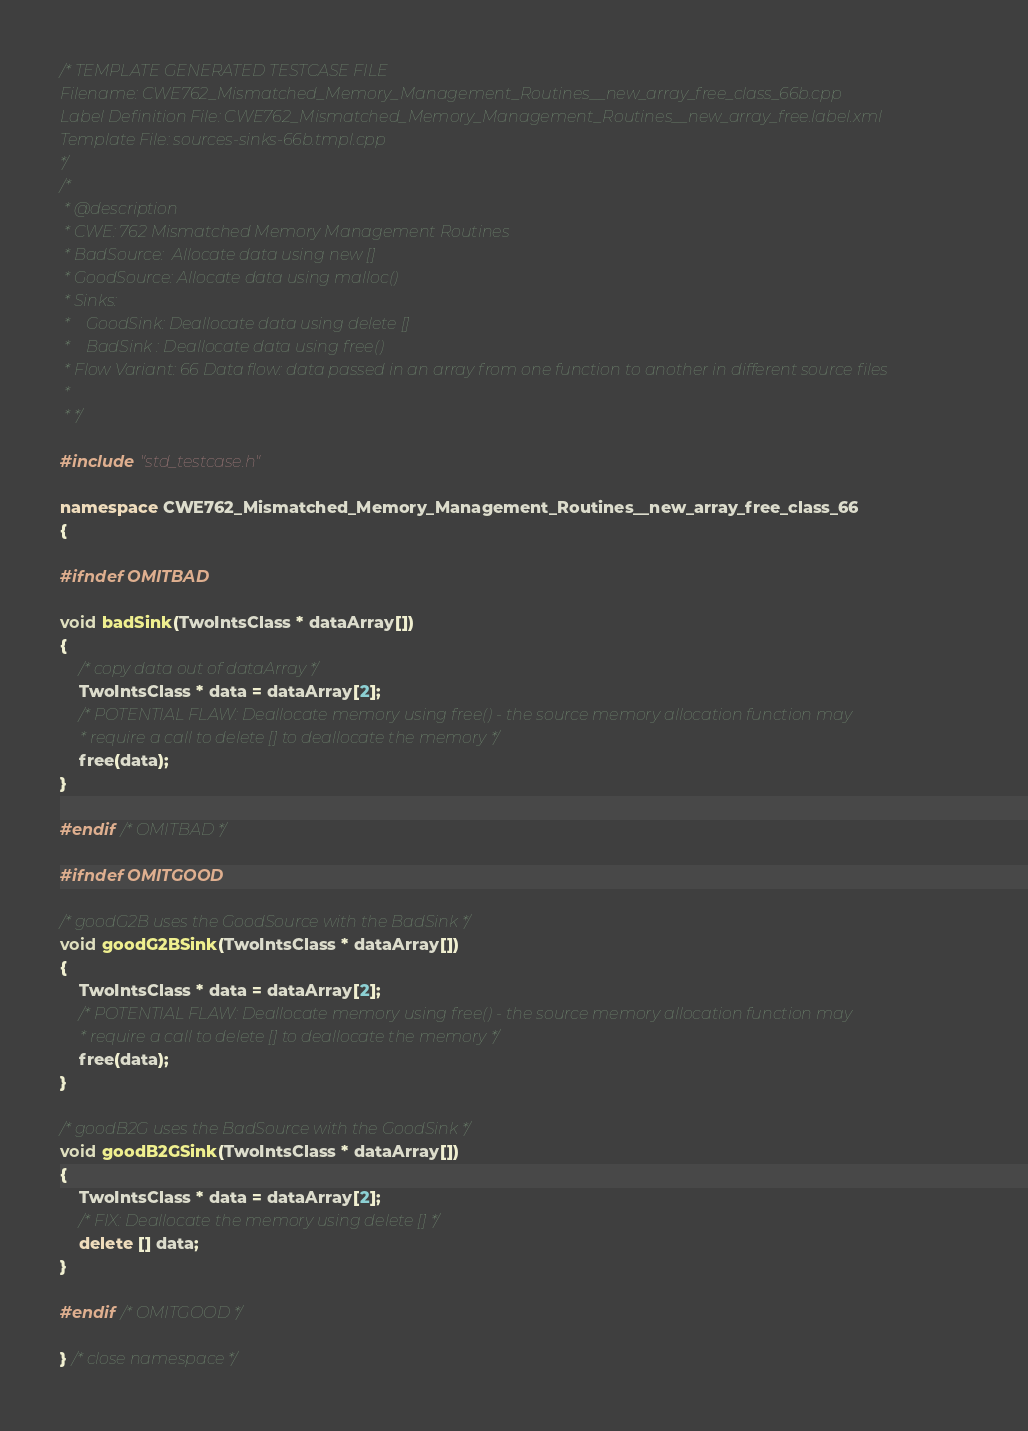<code> <loc_0><loc_0><loc_500><loc_500><_C++_>/* TEMPLATE GENERATED TESTCASE FILE
Filename: CWE762_Mismatched_Memory_Management_Routines__new_array_free_class_66b.cpp
Label Definition File: CWE762_Mismatched_Memory_Management_Routines__new_array_free.label.xml
Template File: sources-sinks-66b.tmpl.cpp
*/
/*
 * @description
 * CWE: 762 Mismatched Memory Management Routines
 * BadSource:  Allocate data using new []
 * GoodSource: Allocate data using malloc()
 * Sinks:
 *    GoodSink: Deallocate data using delete []
 *    BadSink : Deallocate data using free()
 * Flow Variant: 66 Data flow: data passed in an array from one function to another in different source files
 *
 * */

#include "std_testcase.h"

namespace CWE762_Mismatched_Memory_Management_Routines__new_array_free_class_66
{

#ifndef OMITBAD

void badSink(TwoIntsClass * dataArray[])
{
    /* copy data out of dataArray */
    TwoIntsClass * data = dataArray[2];
    /* POTENTIAL FLAW: Deallocate memory using free() - the source memory allocation function may
     * require a call to delete [] to deallocate the memory */
    free(data);
}

#endif /* OMITBAD */

#ifndef OMITGOOD

/* goodG2B uses the GoodSource with the BadSink */
void goodG2BSink(TwoIntsClass * dataArray[])
{
    TwoIntsClass * data = dataArray[2];
    /* POTENTIAL FLAW: Deallocate memory using free() - the source memory allocation function may
     * require a call to delete [] to deallocate the memory */
    free(data);
}

/* goodB2G uses the BadSource with the GoodSink */
void goodB2GSink(TwoIntsClass * dataArray[])
{
    TwoIntsClass * data = dataArray[2];
    /* FIX: Deallocate the memory using delete [] */
    delete [] data;
}

#endif /* OMITGOOD */

} /* close namespace */
</code> 